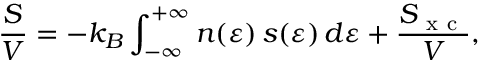Convert formula to latex. <formula><loc_0><loc_0><loc_500><loc_500>\frac { S } { V } = - k _ { B } \int _ { - \infty } ^ { + \infty } n ( \varepsilon ) \, s ( \varepsilon ) \, d \varepsilon + \frac { S _ { x c } } { V } ,</formula> 